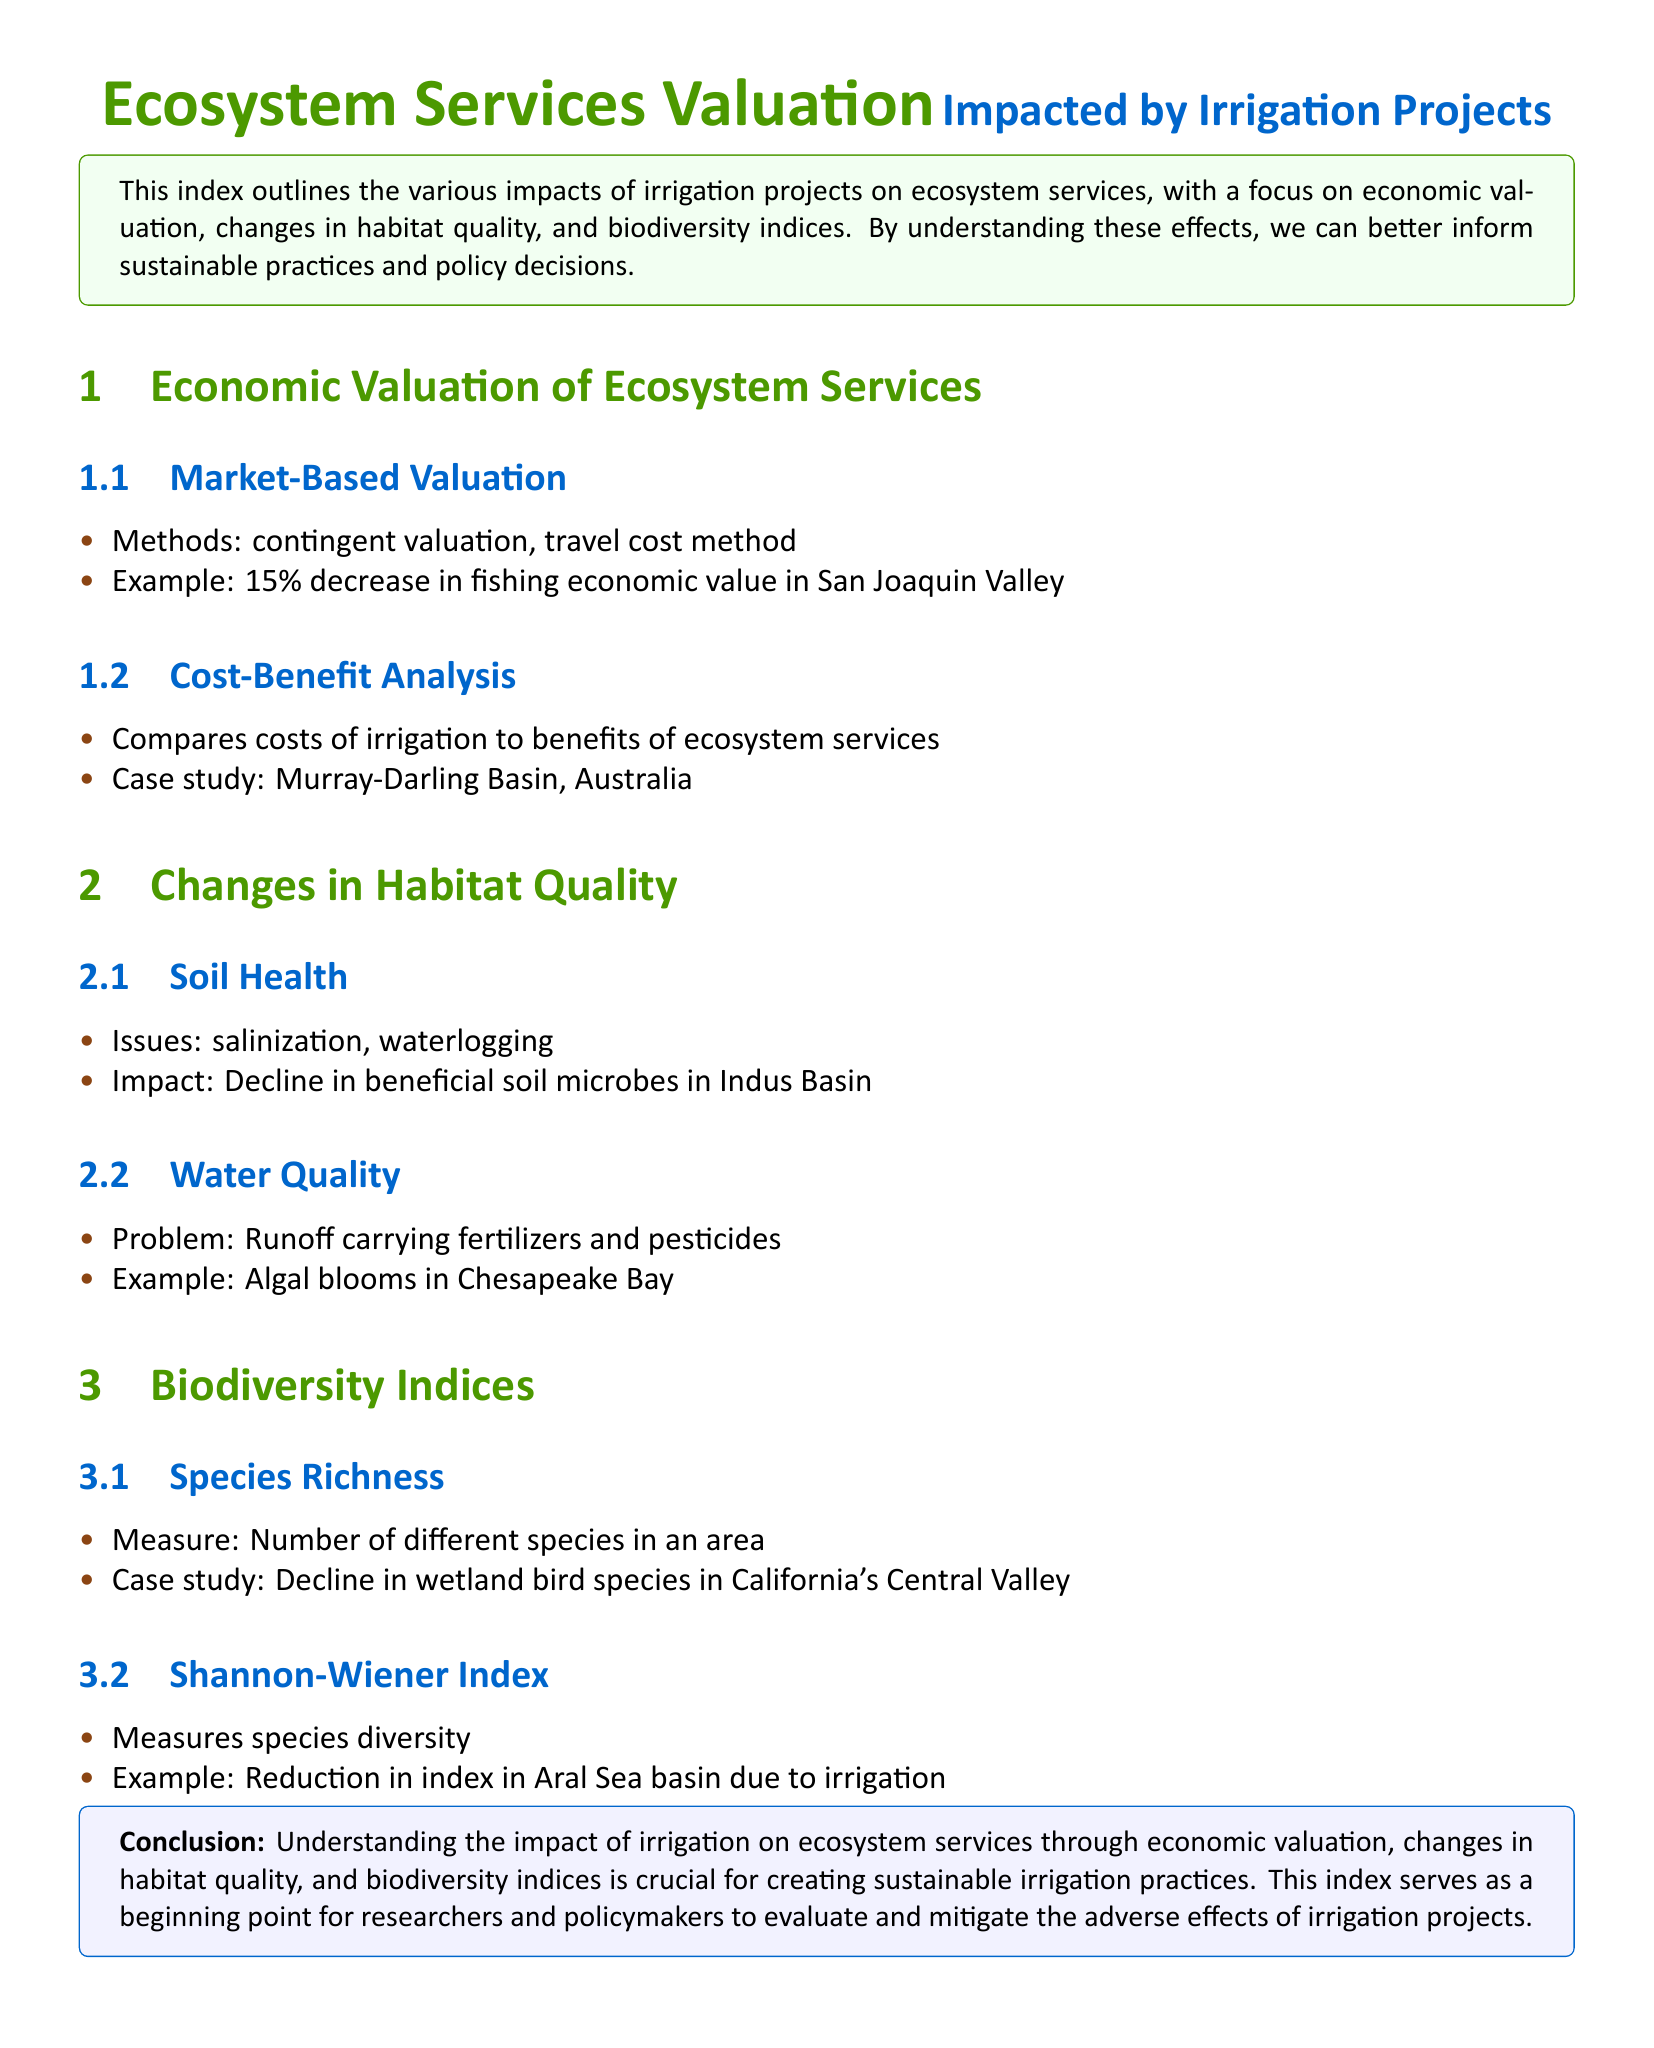What are the methods for market-based valuation? The document states that the methods for market-based valuation include contingent valuation and travel cost method.
Answer: contingent valuation, travel cost method What is the economic value decrease in San Joaquin Valley? The document provides an example showing a 15% decrease in fishing economic value in San Joaquin Valley.
Answer: 15% What are two issues affecting soil health due to irrigation? The document lists salinization and waterlogging as issues affecting soil health.
Answer: salinization, waterlogging What example of water quality problem is mentioned? The document describes the problem of runoff carrying fertilizers and pesticides, citing algal blooms in Chesapeake Bay as an example.
Answer: algal blooms in Chesapeake Bay What case study highlights cost-benefit analysis of irrigation? The document mentions the Murray-Darling Basin in Australia as a case study for cost-benefit analysis.
Answer: Murray-Darling Basin, Australia What is measured by the Shannon-Wiener Index? The document specifies that the Shannon-Wiener Index measures species diversity.
Answer: species diversity What type of species decline is noted in California's Central Valley? The document refers to the decline in wetland bird species in California's Central Valley.
Answer: wetland bird species What is a crucial aspect for creating sustainable irrigation practices according to the conclusion? The conclusion emphasizes the understanding of the impact of irrigation on ecosystem services as crucial for sustainable practices.
Answer: understanding the impact of irrigation on ecosystem services 